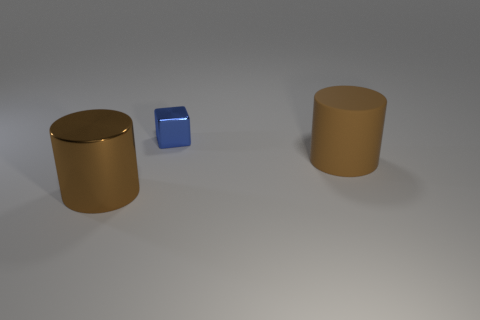What shape is the thing that is the same size as the matte cylinder?
Offer a terse response. Cylinder. What number of large things are cylinders or metal objects?
Your response must be concise. 2. Is there a blue shiny block in front of the big brown object that is to the right of the large object left of the tiny blue object?
Ensure brevity in your answer.  No. Is there a brown rubber cylinder that has the same size as the blue shiny thing?
Offer a very short reply. No. What is the material of the other object that is the same size as the brown metal object?
Give a very brief answer. Rubber. There is a blue shiny cube; does it have the same size as the cylinder that is in front of the big brown matte cylinder?
Your answer should be compact. No. How many matte objects are either cylinders or blue cubes?
Your response must be concise. 1. How many big matte objects are the same shape as the tiny blue metal object?
Offer a terse response. 0. What is the material of the cylinder that is the same color as the big metal object?
Provide a short and direct response. Rubber. There is a brown object that is to the left of the blue shiny object; is its size the same as the brown thing that is behind the large brown metal thing?
Give a very brief answer. Yes. 